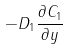Convert formula to latex. <formula><loc_0><loc_0><loc_500><loc_500>- D _ { 1 } \frac { \partial C _ { 1 } } { \partial y }</formula> 